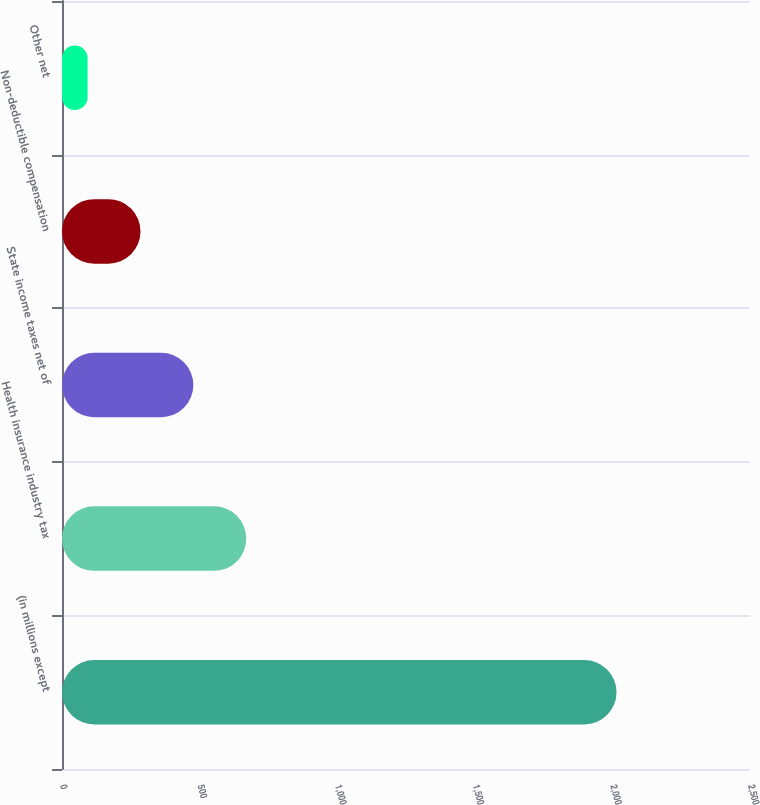Convert chart to OTSL. <chart><loc_0><loc_0><loc_500><loc_500><bar_chart><fcel>(in millions except<fcel>Health insurance industry tax<fcel>State income taxes net of<fcel>Non-deductible compensation<fcel>Other net<nl><fcel>2015<fcel>669.6<fcel>477.4<fcel>285.2<fcel>93<nl></chart> 